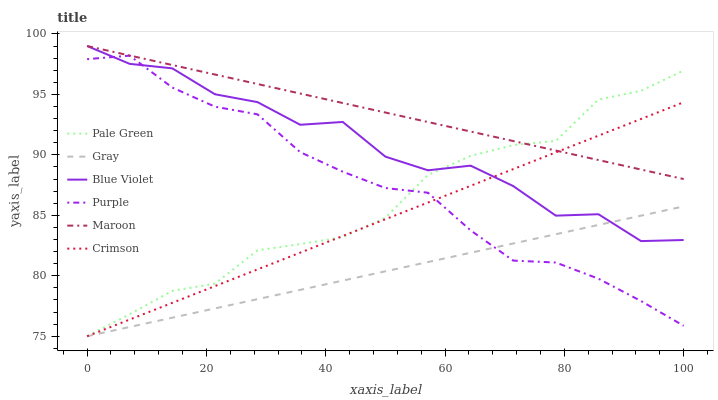Does Gray have the minimum area under the curve?
Answer yes or no. Yes. Does Maroon have the maximum area under the curve?
Answer yes or no. Yes. Does Purple have the minimum area under the curve?
Answer yes or no. No. Does Purple have the maximum area under the curve?
Answer yes or no. No. Is Maroon the smoothest?
Answer yes or no. Yes. Is Blue Violet the roughest?
Answer yes or no. Yes. Is Purple the smoothest?
Answer yes or no. No. Is Purple the roughest?
Answer yes or no. No. Does Gray have the lowest value?
Answer yes or no. Yes. Does Purple have the lowest value?
Answer yes or no. No. Does Blue Violet have the highest value?
Answer yes or no. Yes. Does Purple have the highest value?
Answer yes or no. No. Is Purple less than Maroon?
Answer yes or no. Yes. Is Maroon greater than Gray?
Answer yes or no. Yes. Does Purple intersect Crimson?
Answer yes or no. Yes. Is Purple less than Crimson?
Answer yes or no. No. Is Purple greater than Crimson?
Answer yes or no. No. Does Purple intersect Maroon?
Answer yes or no. No. 